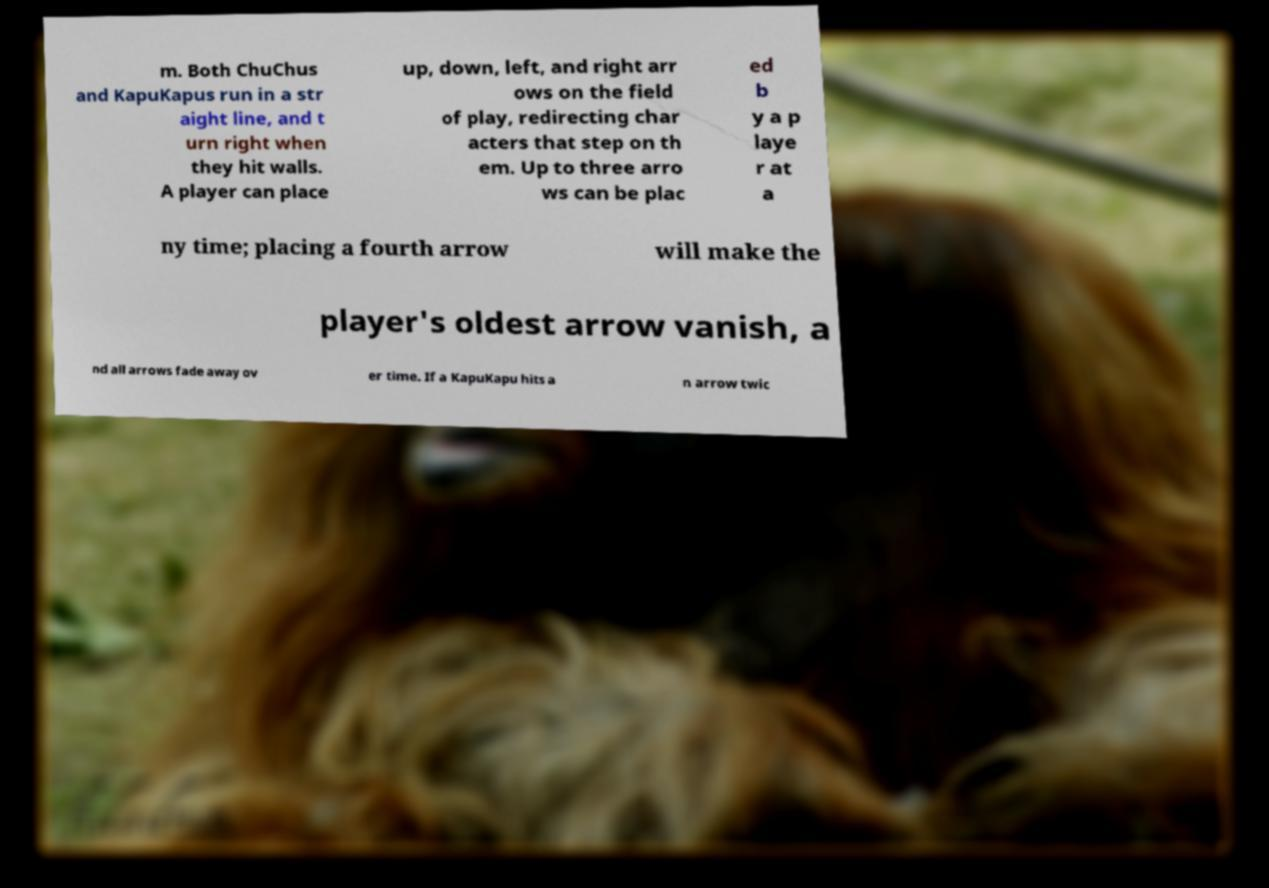For documentation purposes, I need the text within this image transcribed. Could you provide that? m. Both ChuChus and KapuKapus run in a str aight line, and t urn right when they hit walls. A player can place up, down, left, and right arr ows on the field of play, redirecting char acters that step on th em. Up to three arro ws can be plac ed b y a p laye r at a ny time; placing a fourth arrow will make the player's oldest arrow vanish, a nd all arrows fade away ov er time. If a KapuKapu hits a n arrow twic 